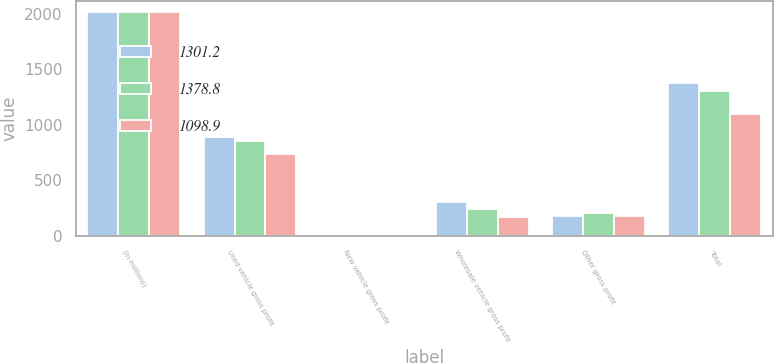Convert chart to OTSL. <chart><loc_0><loc_0><loc_500><loc_500><stacked_bar_chart><ecel><fcel>(In millions)<fcel>Used vehicle gross profit<fcel>New vehicle gross profit<fcel>Wholesale vehicle gross profit<fcel>Other gross profit<fcel>Total<nl><fcel>1301.2<fcel>2012<fcel>888.6<fcel>6.5<fcel>301.8<fcel>181.9<fcel>1378.8<nl><fcel>1378.8<fcel>2011<fcel>854<fcel>5.4<fcel>238.8<fcel>203<fcel>1301.2<nl><fcel>1098.9<fcel>2010<fcel>739.9<fcel>6.7<fcel>171.5<fcel>180.8<fcel>1098.9<nl></chart> 